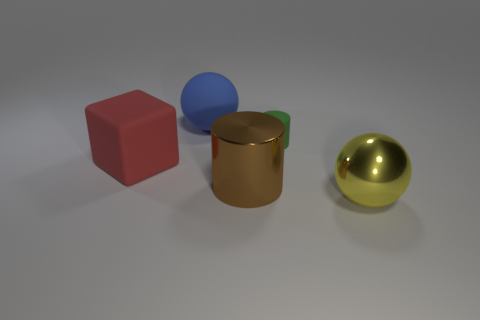Can you infer anything about the lighting in this scene? The lighting in the image seems to be soft and diffused, which is indicated by the gentle shadows under the objects and the muted reflections on them. There are no harsh highlights or strong contrast in the shadows, suggesting the light source is not extremely bright, or there may be some form of light diffusion in place, like a softbox or an overcast sky. 